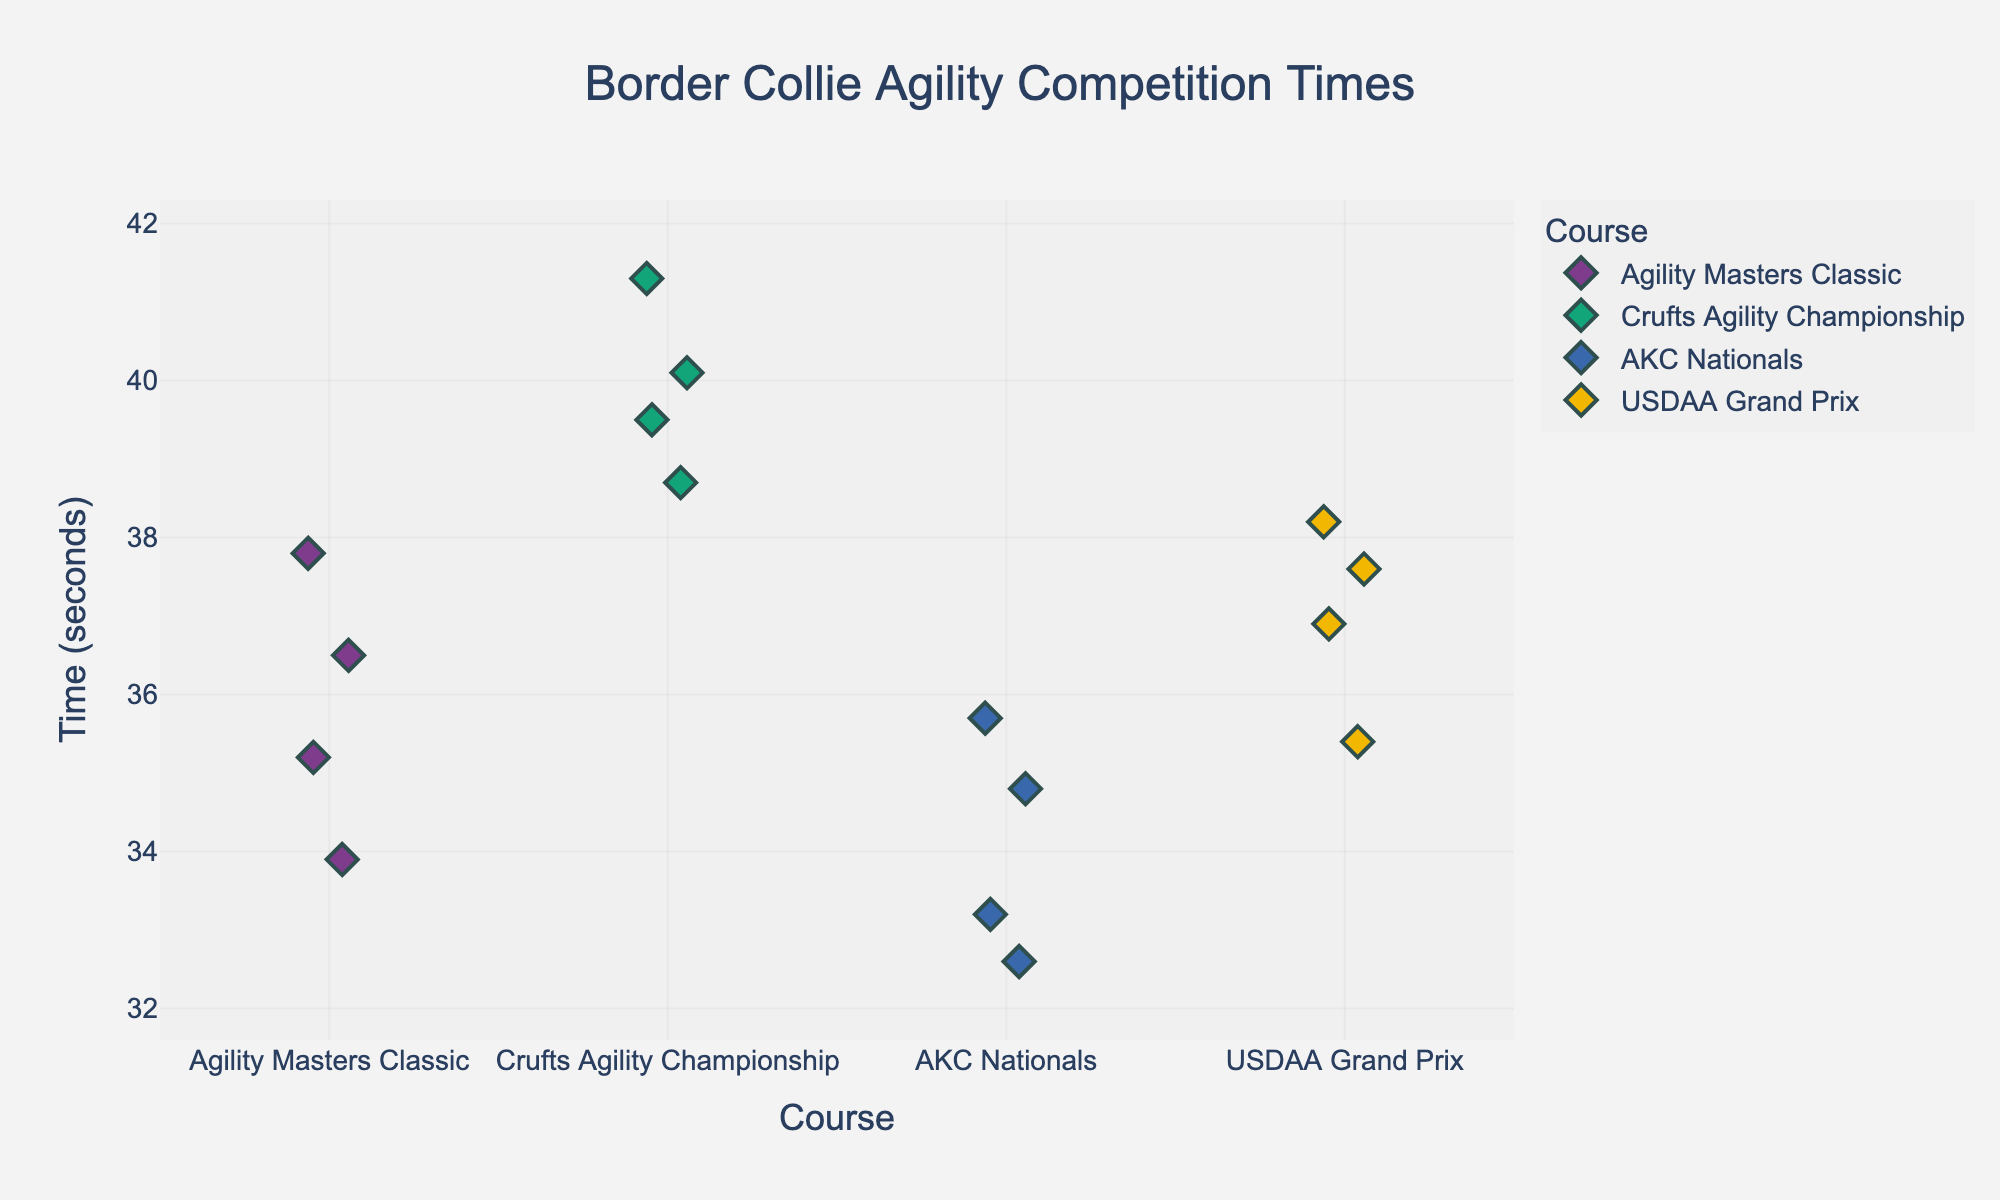How many obstacle courses are displayed in the figure? There are four different courses shown in the figure: "Agility Masters Classic," "Crufts Agility Championship," "AKC Nationals," and "USDAA Grand Prix."
Answer: Four Which course has the quickest time? By examining the plotted points on the y-axis, the lowest time recorded is around 32.6 seconds, which belongs to the "AKC Nationals" course.
Answer: AKC Nationals What is the range of times for the "Crufts Agility Championship"? The times for the "Crufts Agility Championship" range from approximately 38.7 to 41.3 seconds. This can be seen from the spread of the data points associated with this course.
Answer: 38.7 to 41.3 seconds Which course has the highest variability in times? The course with the highest variability has times that are more spread out on the y-axis. Observing the plot, "Crufts Agility Championship" appears to have the largest spread of times from around 38.7 to 41.3 seconds, indicating high variability.
Answer: Crufts Agility Championship Is the median time for "USDAA Grand Prix" higher or lower than "Agility Masters Classic"? To determine the median, we look at the middle value of each course. For "USDAA Grand Prix," the times are roughly centered around 37.0 seconds. For "Agility Masters Classic," the times are centered around 36.0 seconds. Thus, "USDAA Grand Prix" has a higher median time.
Answer: Higher Which course shows the least dispersion in times? The least dispersed course will have data points closest together. "AKC Nationals" has a tight range of times between 32.6 and 35.7 seconds, indicating the least dispersion.
Answer: AKC Nationals What's the average time for "Agility Masters Classic"? To find the average, add all times for "Agility Masters Classic" and divide by the number of points: (35.2 + 37.8 + 33.9 + 36.5)/4 = 35.85 seconds.
Answer: 35.85 seconds How does the quickest time in "USDAA Grand Prix" compare to the quickest time in "Crufts Agility Championship"? The quickest time in "USDAA Grand Prix" is around 35.4 seconds, while in "Crufts Agility Championship," it's around 38.7 seconds. Thus, "USDAA Grand Prix" is quicker.
Answer: USDAA Grand Prix is quicker Which course has the closest average to 35 seconds? Calculate the average times for each course and compare them to 35 seconds. "Agility Masters Classic" has an average time of 35.85 seconds, "Crufts Agility Championship" has around 39.9 seconds, "AKC Nationals" around 34.08 seconds, and "USDAA Grand Prix" around 37.03 seconds. "AKC Nationals" is closest to 35 seconds.
Answer: AKC Nationals Is there any overlap in the time ranges between "Agility Masters Classic" and "USDAA Grand Prix"? Checking the ranges, "Agility Masters Classic" has times between 33.9 to 37.8 seconds, and "USDAA Grand Prix" has times between 35.4 to 38.2 seconds. There is an overlap in where times range from about 35.4 to 37.8 seconds.
Answer: Yes 